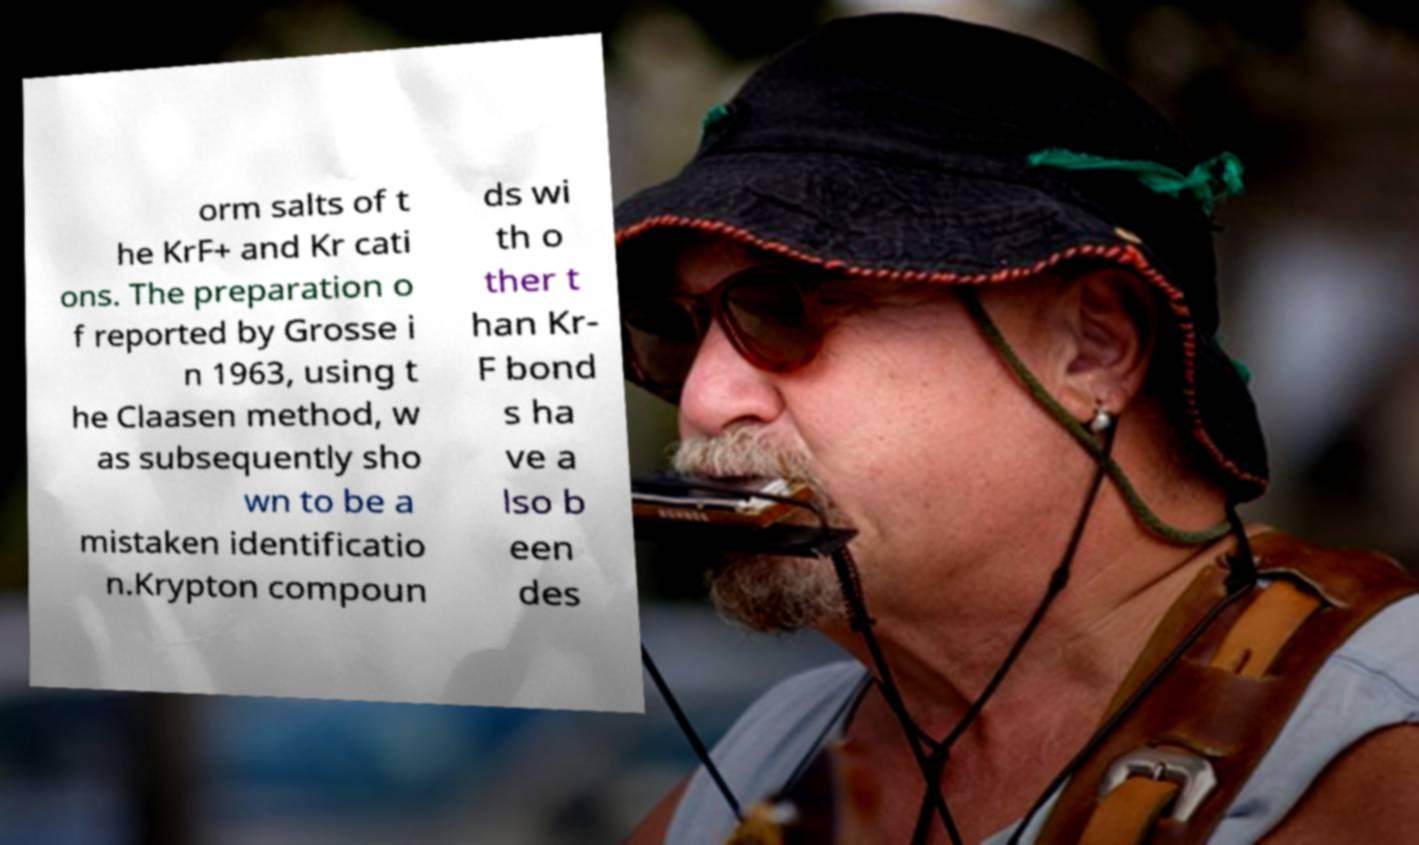Could you extract and type out the text from this image? orm salts of t he KrF+ and Kr cati ons. The preparation o f reported by Grosse i n 1963, using t he Claasen method, w as subsequently sho wn to be a mistaken identificatio n.Krypton compoun ds wi th o ther t han Kr- F bond s ha ve a lso b een des 